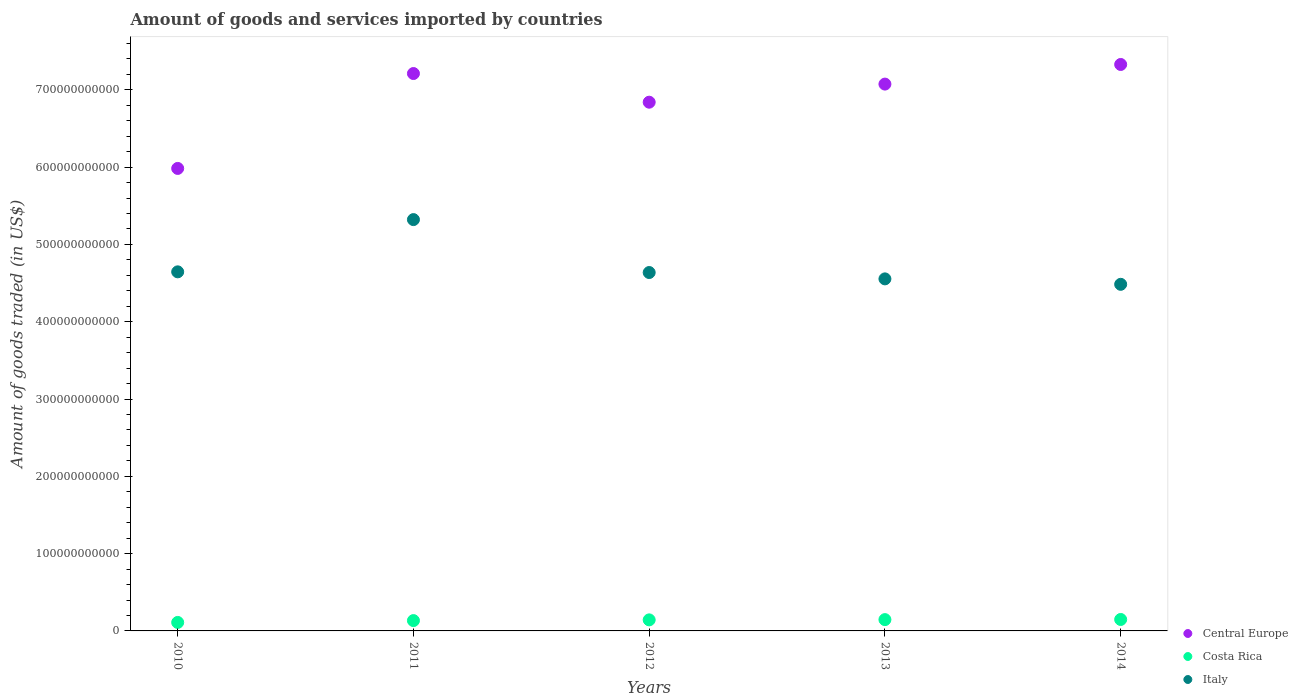Is the number of dotlines equal to the number of legend labels?
Ensure brevity in your answer.  Yes. What is the total amount of goods and services imported in Central Europe in 2010?
Provide a succinct answer. 5.98e+11. Across all years, what is the maximum total amount of goods and services imported in Italy?
Your response must be concise. 5.32e+11. Across all years, what is the minimum total amount of goods and services imported in Italy?
Your answer should be compact. 4.48e+11. In which year was the total amount of goods and services imported in Italy maximum?
Provide a succinct answer. 2011. What is the total total amount of goods and services imported in Central Europe in the graph?
Offer a very short reply. 3.44e+12. What is the difference between the total amount of goods and services imported in Central Europe in 2011 and that in 2014?
Give a very brief answer. -1.17e+1. What is the difference between the total amount of goods and services imported in Italy in 2011 and the total amount of goods and services imported in Central Europe in 2010?
Keep it short and to the point. -6.62e+1. What is the average total amount of goods and services imported in Italy per year?
Offer a very short reply. 4.73e+11. In the year 2012, what is the difference between the total amount of goods and services imported in Costa Rica and total amount of goods and services imported in Italy?
Your response must be concise. -4.49e+11. What is the ratio of the total amount of goods and services imported in Costa Rica in 2011 to that in 2012?
Your answer should be very brief. 0.93. Is the total amount of goods and services imported in Costa Rica in 2010 less than that in 2014?
Your response must be concise. Yes. Is the difference between the total amount of goods and services imported in Costa Rica in 2010 and 2013 greater than the difference between the total amount of goods and services imported in Italy in 2010 and 2013?
Offer a very short reply. No. What is the difference between the highest and the second highest total amount of goods and services imported in Costa Rica?
Offer a terse response. 1.86e+08. What is the difference between the highest and the lowest total amount of goods and services imported in Costa Rica?
Offer a terse response. 3.83e+09. In how many years, is the total amount of goods and services imported in Italy greater than the average total amount of goods and services imported in Italy taken over all years?
Make the answer very short. 1. Is the total amount of goods and services imported in Costa Rica strictly less than the total amount of goods and services imported in Central Europe over the years?
Offer a terse response. Yes. How many years are there in the graph?
Make the answer very short. 5. What is the difference between two consecutive major ticks on the Y-axis?
Your response must be concise. 1.00e+11. Does the graph contain grids?
Make the answer very short. No. How many legend labels are there?
Ensure brevity in your answer.  3. What is the title of the graph?
Your answer should be compact. Amount of goods and services imported by countries. What is the label or title of the X-axis?
Keep it short and to the point. Years. What is the label or title of the Y-axis?
Offer a terse response. Amount of goods traded (in US$). What is the Amount of goods traded (in US$) of Central Europe in 2010?
Offer a terse response. 5.98e+11. What is the Amount of goods traded (in US$) of Costa Rica in 2010?
Provide a succinct answer. 1.10e+1. What is the Amount of goods traded (in US$) of Italy in 2010?
Ensure brevity in your answer.  4.65e+11. What is the Amount of goods traded (in US$) in Central Europe in 2011?
Keep it short and to the point. 7.21e+11. What is the Amount of goods traded (in US$) in Costa Rica in 2011?
Make the answer very short. 1.34e+1. What is the Amount of goods traded (in US$) of Italy in 2011?
Ensure brevity in your answer.  5.32e+11. What is the Amount of goods traded (in US$) of Central Europe in 2012?
Ensure brevity in your answer.  6.84e+11. What is the Amount of goods traded (in US$) of Costa Rica in 2012?
Offer a terse response. 1.43e+1. What is the Amount of goods traded (in US$) of Italy in 2012?
Give a very brief answer. 4.64e+11. What is the Amount of goods traded (in US$) in Central Europe in 2013?
Make the answer very short. 7.07e+11. What is the Amount of goods traded (in US$) in Costa Rica in 2013?
Offer a terse response. 1.46e+1. What is the Amount of goods traded (in US$) in Italy in 2013?
Provide a short and direct response. 4.55e+11. What is the Amount of goods traded (in US$) in Central Europe in 2014?
Provide a short and direct response. 7.33e+11. What is the Amount of goods traded (in US$) in Costa Rica in 2014?
Keep it short and to the point. 1.48e+1. What is the Amount of goods traded (in US$) in Italy in 2014?
Ensure brevity in your answer.  4.48e+11. Across all years, what is the maximum Amount of goods traded (in US$) of Central Europe?
Your answer should be very brief. 7.33e+11. Across all years, what is the maximum Amount of goods traded (in US$) of Costa Rica?
Provide a succinct answer. 1.48e+1. Across all years, what is the maximum Amount of goods traded (in US$) in Italy?
Your answer should be very brief. 5.32e+11. Across all years, what is the minimum Amount of goods traded (in US$) in Central Europe?
Provide a succinct answer. 5.98e+11. Across all years, what is the minimum Amount of goods traded (in US$) of Costa Rica?
Offer a terse response. 1.10e+1. Across all years, what is the minimum Amount of goods traded (in US$) of Italy?
Give a very brief answer. 4.48e+11. What is the total Amount of goods traded (in US$) in Central Europe in the graph?
Offer a very short reply. 3.44e+12. What is the total Amount of goods traded (in US$) in Costa Rica in the graph?
Make the answer very short. 6.81e+1. What is the total Amount of goods traded (in US$) of Italy in the graph?
Make the answer very short. 2.36e+12. What is the difference between the Amount of goods traded (in US$) of Central Europe in 2010 and that in 2011?
Offer a terse response. -1.23e+11. What is the difference between the Amount of goods traded (in US$) in Costa Rica in 2010 and that in 2011?
Provide a succinct answer. -2.38e+09. What is the difference between the Amount of goods traded (in US$) of Italy in 2010 and that in 2011?
Give a very brief answer. -6.76e+1. What is the difference between the Amount of goods traded (in US$) in Central Europe in 2010 and that in 2012?
Offer a very short reply. -8.57e+1. What is the difference between the Amount of goods traded (in US$) of Costa Rica in 2010 and that in 2012?
Provide a short and direct response. -3.31e+09. What is the difference between the Amount of goods traded (in US$) in Italy in 2010 and that in 2012?
Give a very brief answer. 8.82e+08. What is the difference between the Amount of goods traded (in US$) in Central Europe in 2010 and that in 2013?
Your answer should be very brief. -1.09e+11. What is the difference between the Amount of goods traded (in US$) of Costa Rica in 2010 and that in 2013?
Make the answer very short. -3.65e+09. What is the difference between the Amount of goods traded (in US$) in Italy in 2010 and that in 2013?
Make the answer very short. 9.10e+09. What is the difference between the Amount of goods traded (in US$) in Central Europe in 2010 and that in 2014?
Give a very brief answer. -1.34e+11. What is the difference between the Amount of goods traded (in US$) in Costa Rica in 2010 and that in 2014?
Provide a succinct answer. -3.83e+09. What is the difference between the Amount of goods traded (in US$) in Italy in 2010 and that in 2014?
Provide a short and direct response. 1.61e+1. What is the difference between the Amount of goods traded (in US$) of Central Europe in 2011 and that in 2012?
Give a very brief answer. 3.71e+1. What is the difference between the Amount of goods traded (in US$) in Costa Rica in 2011 and that in 2012?
Provide a short and direct response. -9.36e+08. What is the difference between the Amount of goods traded (in US$) of Italy in 2011 and that in 2012?
Give a very brief answer. 6.85e+1. What is the difference between the Amount of goods traded (in US$) in Central Europe in 2011 and that in 2013?
Ensure brevity in your answer.  1.37e+1. What is the difference between the Amount of goods traded (in US$) of Costa Rica in 2011 and that in 2013?
Ensure brevity in your answer.  -1.27e+09. What is the difference between the Amount of goods traded (in US$) in Italy in 2011 and that in 2013?
Offer a very short reply. 7.67e+1. What is the difference between the Amount of goods traded (in US$) of Central Europe in 2011 and that in 2014?
Your answer should be very brief. -1.17e+1. What is the difference between the Amount of goods traded (in US$) in Costa Rica in 2011 and that in 2014?
Your response must be concise. -1.46e+09. What is the difference between the Amount of goods traded (in US$) in Italy in 2011 and that in 2014?
Offer a terse response. 8.37e+1. What is the difference between the Amount of goods traded (in US$) in Central Europe in 2012 and that in 2013?
Give a very brief answer. -2.34e+1. What is the difference between the Amount of goods traded (in US$) of Costa Rica in 2012 and that in 2013?
Provide a short and direct response. -3.34e+08. What is the difference between the Amount of goods traded (in US$) in Italy in 2012 and that in 2013?
Keep it short and to the point. 8.22e+09. What is the difference between the Amount of goods traded (in US$) in Central Europe in 2012 and that in 2014?
Offer a very short reply. -4.88e+1. What is the difference between the Amount of goods traded (in US$) in Costa Rica in 2012 and that in 2014?
Your answer should be compact. -5.20e+08. What is the difference between the Amount of goods traded (in US$) of Italy in 2012 and that in 2014?
Ensure brevity in your answer.  1.53e+1. What is the difference between the Amount of goods traded (in US$) of Central Europe in 2013 and that in 2014?
Offer a very short reply. -2.54e+1. What is the difference between the Amount of goods traded (in US$) in Costa Rica in 2013 and that in 2014?
Your answer should be very brief. -1.86e+08. What is the difference between the Amount of goods traded (in US$) of Italy in 2013 and that in 2014?
Ensure brevity in your answer.  7.04e+09. What is the difference between the Amount of goods traded (in US$) in Central Europe in 2010 and the Amount of goods traded (in US$) in Costa Rica in 2011?
Provide a short and direct response. 5.85e+11. What is the difference between the Amount of goods traded (in US$) in Central Europe in 2010 and the Amount of goods traded (in US$) in Italy in 2011?
Provide a short and direct response. 6.62e+1. What is the difference between the Amount of goods traded (in US$) of Costa Rica in 2010 and the Amount of goods traded (in US$) of Italy in 2011?
Your answer should be very brief. -5.21e+11. What is the difference between the Amount of goods traded (in US$) of Central Europe in 2010 and the Amount of goods traded (in US$) of Costa Rica in 2012?
Your response must be concise. 5.84e+11. What is the difference between the Amount of goods traded (in US$) in Central Europe in 2010 and the Amount of goods traded (in US$) in Italy in 2012?
Give a very brief answer. 1.35e+11. What is the difference between the Amount of goods traded (in US$) of Costa Rica in 2010 and the Amount of goods traded (in US$) of Italy in 2012?
Make the answer very short. -4.53e+11. What is the difference between the Amount of goods traded (in US$) of Central Europe in 2010 and the Amount of goods traded (in US$) of Costa Rica in 2013?
Provide a succinct answer. 5.84e+11. What is the difference between the Amount of goods traded (in US$) of Central Europe in 2010 and the Amount of goods traded (in US$) of Italy in 2013?
Offer a very short reply. 1.43e+11. What is the difference between the Amount of goods traded (in US$) of Costa Rica in 2010 and the Amount of goods traded (in US$) of Italy in 2013?
Ensure brevity in your answer.  -4.44e+11. What is the difference between the Amount of goods traded (in US$) of Central Europe in 2010 and the Amount of goods traded (in US$) of Costa Rica in 2014?
Your response must be concise. 5.84e+11. What is the difference between the Amount of goods traded (in US$) of Central Europe in 2010 and the Amount of goods traded (in US$) of Italy in 2014?
Make the answer very short. 1.50e+11. What is the difference between the Amount of goods traded (in US$) in Costa Rica in 2010 and the Amount of goods traded (in US$) in Italy in 2014?
Your answer should be very brief. -4.37e+11. What is the difference between the Amount of goods traded (in US$) of Central Europe in 2011 and the Amount of goods traded (in US$) of Costa Rica in 2012?
Provide a succinct answer. 7.07e+11. What is the difference between the Amount of goods traded (in US$) of Central Europe in 2011 and the Amount of goods traded (in US$) of Italy in 2012?
Provide a succinct answer. 2.57e+11. What is the difference between the Amount of goods traded (in US$) of Costa Rica in 2011 and the Amount of goods traded (in US$) of Italy in 2012?
Your answer should be very brief. -4.50e+11. What is the difference between the Amount of goods traded (in US$) in Central Europe in 2011 and the Amount of goods traded (in US$) in Costa Rica in 2013?
Give a very brief answer. 7.06e+11. What is the difference between the Amount of goods traded (in US$) in Central Europe in 2011 and the Amount of goods traded (in US$) in Italy in 2013?
Make the answer very short. 2.66e+11. What is the difference between the Amount of goods traded (in US$) of Costa Rica in 2011 and the Amount of goods traded (in US$) of Italy in 2013?
Ensure brevity in your answer.  -4.42e+11. What is the difference between the Amount of goods traded (in US$) of Central Europe in 2011 and the Amount of goods traded (in US$) of Costa Rica in 2014?
Make the answer very short. 7.06e+11. What is the difference between the Amount of goods traded (in US$) in Central Europe in 2011 and the Amount of goods traded (in US$) in Italy in 2014?
Keep it short and to the point. 2.73e+11. What is the difference between the Amount of goods traded (in US$) in Costa Rica in 2011 and the Amount of goods traded (in US$) in Italy in 2014?
Keep it short and to the point. -4.35e+11. What is the difference between the Amount of goods traded (in US$) of Central Europe in 2012 and the Amount of goods traded (in US$) of Costa Rica in 2013?
Make the answer very short. 6.69e+11. What is the difference between the Amount of goods traded (in US$) of Central Europe in 2012 and the Amount of goods traded (in US$) of Italy in 2013?
Offer a very short reply. 2.29e+11. What is the difference between the Amount of goods traded (in US$) in Costa Rica in 2012 and the Amount of goods traded (in US$) in Italy in 2013?
Your answer should be very brief. -4.41e+11. What is the difference between the Amount of goods traded (in US$) of Central Europe in 2012 and the Amount of goods traded (in US$) of Costa Rica in 2014?
Your answer should be very brief. 6.69e+11. What is the difference between the Amount of goods traded (in US$) in Central Europe in 2012 and the Amount of goods traded (in US$) in Italy in 2014?
Ensure brevity in your answer.  2.36e+11. What is the difference between the Amount of goods traded (in US$) of Costa Rica in 2012 and the Amount of goods traded (in US$) of Italy in 2014?
Give a very brief answer. -4.34e+11. What is the difference between the Amount of goods traded (in US$) in Central Europe in 2013 and the Amount of goods traded (in US$) in Costa Rica in 2014?
Make the answer very short. 6.93e+11. What is the difference between the Amount of goods traded (in US$) of Central Europe in 2013 and the Amount of goods traded (in US$) of Italy in 2014?
Offer a terse response. 2.59e+11. What is the difference between the Amount of goods traded (in US$) of Costa Rica in 2013 and the Amount of goods traded (in US$) of Italy in 2014?
Provide a succinct answer. -4.34e+11. What is the average Amount of goods traded (in US$) in Central Europe per year?
Provide a short and direct response. 6.89e+11. What is the average Amount of goods traded (in US$) in Costa Rica per year?
Make the answer very short. 1.36e+1. What is the average Amount of goods traded (in US$) in Italy per year?
Offer a very short reply. 4.73e+11. In the year 2010, what is the difference between the Amount of goods traded (in US$) in Central Europe and Amount of goods traded (in US$) in Costa Rica?
Give a very brief answer. 5.87e+11. In the year 2010, what is the difference between the Amount of goods traded (in US$) in Central Europe and Amount of goods traded (in US$) in Italy?
Offer a very short reply. 1.34e+11. In the year 2010, what is the difference between the Amount of goods traded (in US$) of Costa Rica and Amount of goods traded (in US$) of Italy?
Your response must be concise. -4.54e+11. In the year 2011, what is the difference between the Amount of goods traded (in US$) of Central Europe and Amount of goods traded (in US$) of Costa Rica?
Your answer should be very brief. 7.08e+11. In the year 2011, what is the difference between the Amount of goods traded (in US$) in Central Europe and Amount of goods traded (in US$) in Italy?
Your answer should be compact. 1.89e+11. In the year 2011, what is the difference between the Amount of goods traded (in US$) of Costa Rica and Amount of goods traded (in US$) of Italy?
Provide a short and direct response. -5.19e+11. In the year 2012, what is the difference between the Amount of goods traded (in US$) of Central Europe and Amount of goods traded (in US$) of Costa Rica?
Your answer should be very brief. 6.70e+11. In the year 2012, what is the difference between the Amount of goods traded (in US$) of Central Europe and Amount of goods traded (in US$) of Italy?
Your response must be concise. 2.20e+11. In the year 2012, what is the difference between the Amount of goods traded (in US$) of Costa Rica and Amount of goods traded (in US$) of Italy?
Your response must be concise. -4.49e+11. In the year 2013, what is the difference between the Amount of goods traded (in US$) of Central Europe and Amount of goods traded (in US$) of Costa Rica?
Offer a very short reply. 6.93e+11. In the year 2013, what is the difference between the Amount of goods traded (in US$) in Central Europe and Amount of goods traded (in US$) in Italy?
Keep it short and to the point. 2.52e+11. In the year 2013, what is the difference between the Amount of goods traded (in US$) in Costa Rica and Amount of goods traded (in US$) in Italy?
Provide a succinct answer. -4.41e+11. In the year 2014, what is the difference between the Amount of goods traded (in US$) in Central Europe and Amount of goods traded (in US$) in Costa Rica?
Offer a terse response. 7.18e+11. In the year 2014, what is the difference between the Amount of goods traded (in US$) of Central Europe and Amount of goods traded (in US$) of Italy?
Provide a succinct answer. 2.84e+11. In the year 2014, what is the difference between the Amount of goods traded (in US$) in Costa Rica and Amount of goods traded (in US$) in Italy?
Your response must be concise. -4.34e+11. What is the ratio of the Amount of goods traded (in US$) of Central Europe in 2010 to that in 2011?
Your answer should be compact. 0.83. What is the ratio of the Amount of goods traded (in US$) of Costa Rica in 2010 to that in 2011?
Keep it short and to the point. 0.82. What is the ratio of the Amount of goods traded (in US$) of Italy in 2010 to that in 2011?
Your answer should be compact. 0.87. What is the ratio of the Amount of goods traded (in US$) in Central Europe in 2010 to that in 2012?
Make the answer very short. 0.87. What is the ratio of the Amount of goods traded (in US$) of Costa Rica in 2010 to that in 2012?
Keep it short and to the point. 0.77. What is the ratio of the Amount of goods traded (in US$) of Central Europe in 2010 to that in 2013?
Provide a succinct answer. 0.85. What is the ratio of the Amount of goods traded (in US$) of Costa Rica in 2010 to that in 2013?
Ensure brevity in your answer.  0.75. What is the ratio of the Amount of goods traded (in US$) in Central Europe in 2010 to that in 2014?
Keep it short and to the point. 0.82. What is the ratio of the Amount of goods traded (in US$) in Costa Rica in 2010 to that in 2014?
Provide a short and direct response. 0.74. What is the ratio of the Amount of goods traded (in US$) in Italy in 2010 to that in 2014?
Make the answer very short. 1.04. What is the ratio of the Amount of goods traded (in US$) in Central Europe in 2011 to that in 2012?
Offer a terse response. 1.05. What is the ratio of the Amount of goods traded (in US$) in Costa Rica in 2011 to that in 2012?
Provide a succinct answer. 0.93. What is the ratio of the Amount of goods traded (in US$) in Italy in 2011 to that in 2012?
Offer a terse response. 1.15. What is the ratio of the Amount of goods traded (in US$) in Central Europe in 2011 to that in 2013?
Make the answer very short. 1.02. What is the ratio of the Amount of goods traded (in US$) of Costa Rica in 2011 to that in 2013?
Ensure brevity in your answer.  0.91. What is the ratio of the Amount of goods traded (in US$) in Italy in 2011 to that in 2013?
Your answer should be very brief. 1.17. What is the ratio of the Amount of goods traded (in US$) of Central Europe in 2011 to that in 2014?
Your answer should be very brief. 0.98. What is the ratio of the Amount of goods traded (in US$) in Costa Rica in 2011 to that in 2014?
Your answer should be very brief. 0.9. What is the ratio of the Amount of goods traded (in US$) in Italy in 2011 to that in 2014?
Your answer should be compact. 1.19. What is the ratio of the Amount of goods traded (in US$) in Central Europe in 2012 to that in 2013?
Make the answer very short. 0.97. What is the ratio of the Amount of goods traded (in US$) of Costa Rica in 2012 to that in 2013?
Keep it short and to the point. 0.98. What is the ratio of the Amount of goods traded (in US$) in Central Europe in 2012 to that in 2014?
Offer a very short reply. 0.93. What is the ratio of the Amount of goods traded (in US$) in Costa Rica in 2012 to that in 2014?
Keep it short and to the point. 0.96. What is the ratio of the Amount of goods traded (in US$) in Italy in 2012 to that in 2014?
Your answer should be very brief. 1.03. What is the ratio of the Amount of goods traded (in US$) of Central Europe in 2013 to that in 2014?
Offer a terse response. 0.97. What is the ratio of the Amount of goods traded (in US$) in Costa Rica in 2013 to that in 2014?
Make the answer very short. 0.99. What is the ratio of the Amount of goods traded (in US$) in Italy in 2013 to that in 2014?
Provide a succinct answer. 1.02. What is the difference between the highest and the second highest Amount of goods traded (in US$) of Central Europe?
Keep it short and to the point. 1.17e+1. What is the difference between the highest and the second highest Amount of goods traded (in US$) in Costa Rica?
Keep it short and to the point. 1.86e+08. What is the difference between the highest and the second highest Amount of goods traded (in US$) in Italy?
Offer a very short reply. 6.76e+1. What is the difference between the highest and the lowest Amount of goods traded (in US$) in Central Europe?
Offer a very short reply. 1.34e+11. What is the difference between the highest and the lowest Amount of goods traded (in US$) of Costa Rica?
Your answer should be compact. 3.83e+09. What is the difference between the highest and the lowest Amount of goods traded (in US$) of Italy?
Keep it short and to the point. 8.37e+1. 